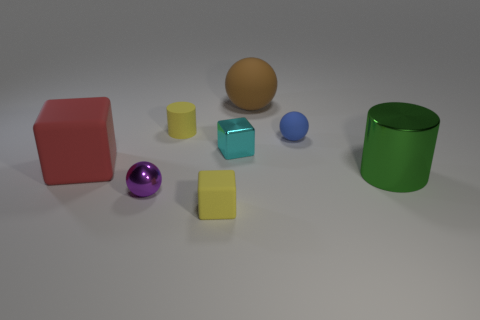Subtract all red rubber cubes. How many cubes are left? 2 Subtract 1 balls. How many balls are left? 2 Add 2 yellow cubes. How many objects exist? 10 Subtract all cylinders. How many objects are left? 6 Add 8 big matte things. How many big matte things are left? 10 Add 3 tiny purple metal things. How many tiny purple metal things exist? 4 Subtract 1 brown balls. How many objects are left? 7 Subtract all matte blocks. Subtract all matte cylinders. How many objects are left? 5 